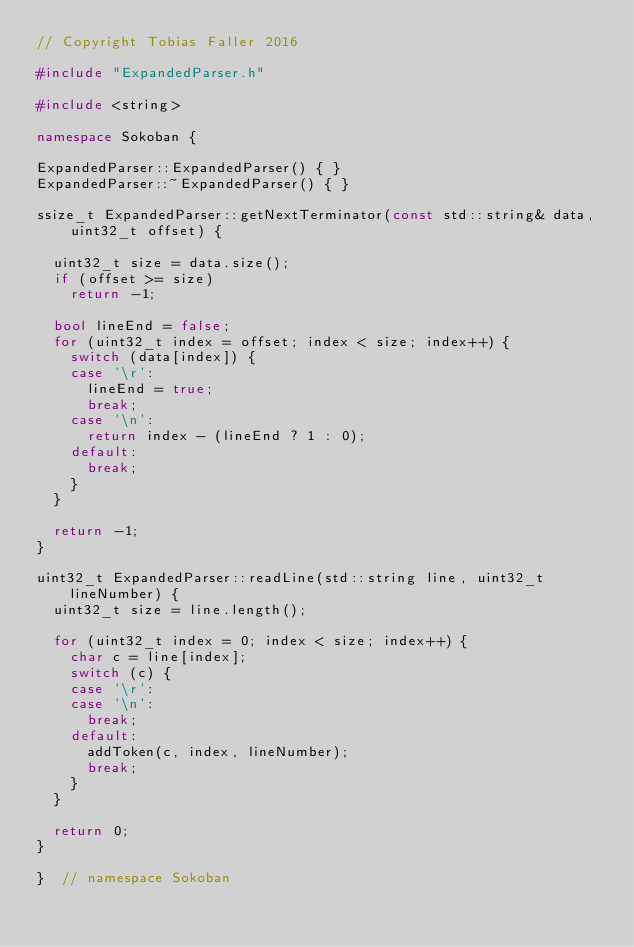<code> <loc_0><loc_0><loc_500><loc_500><_C++_>// Copyright Tobias Faller 2016

#include "ExpandedParser.h"

#include <string>

namespace Sokoban {

ExpandedParser::ExpandedParser() { }
ExpandedParser::~ExpandedParser() { }

ssize_t ExpandedParser::getNextTerminator(const std::string& data,
    uint32_t offset) {

  uint32_t size = data.size();
  if (offset >= size)
    return -1;

  bool lineEnd = false;
  for (uint32_t index = offset; index < size; index++) {
    switch (data[index]) {
    case '\r':
      lineEnd = true;
      break;
    case '\n':
      return index - (lineEnd ? 1 : 0);
    default:
      break;
    }
  }

  return -1;
}

uint32_t ExpandedParser::readLine(std::string line, uint32_t lineNumber) {
  uint32_t size = line.length();

  for (uint32_t index = 0; index < size; index++) {
    char c = line[index];
    switch (c) {
    case '\r':
    case '\n':
      break;
    default:
      addToken(c, index, lineNumber);
      break;
    }
  }

  return 0;
}

}  // namespace Sokoban
</code> 